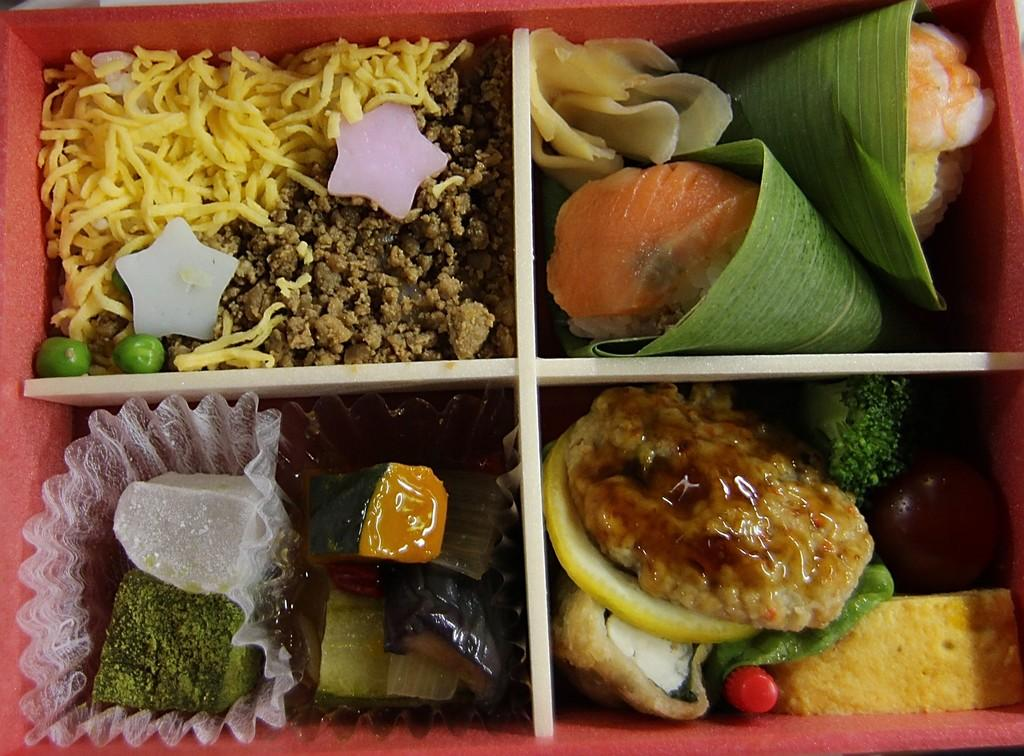What type of objects can be seen in the image? There are food items in the image. How are the food items organized in the image? The food items are in a partitioned box. What type of beam can be seen supporting the train in the image? There is no beam or train present in the image; it only features food items in a partitioned box. 